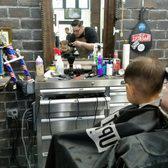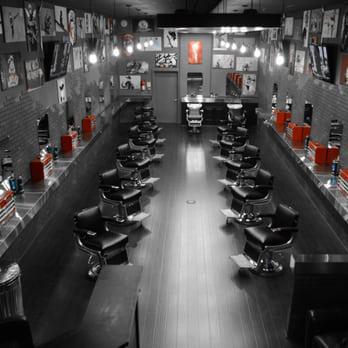The first image is the image on the left, the second image is the image on the right. Examine the images to the left and right. Is the description "Black barber chairs are empty in one image." accurate? Answer yes or no. Yes. 